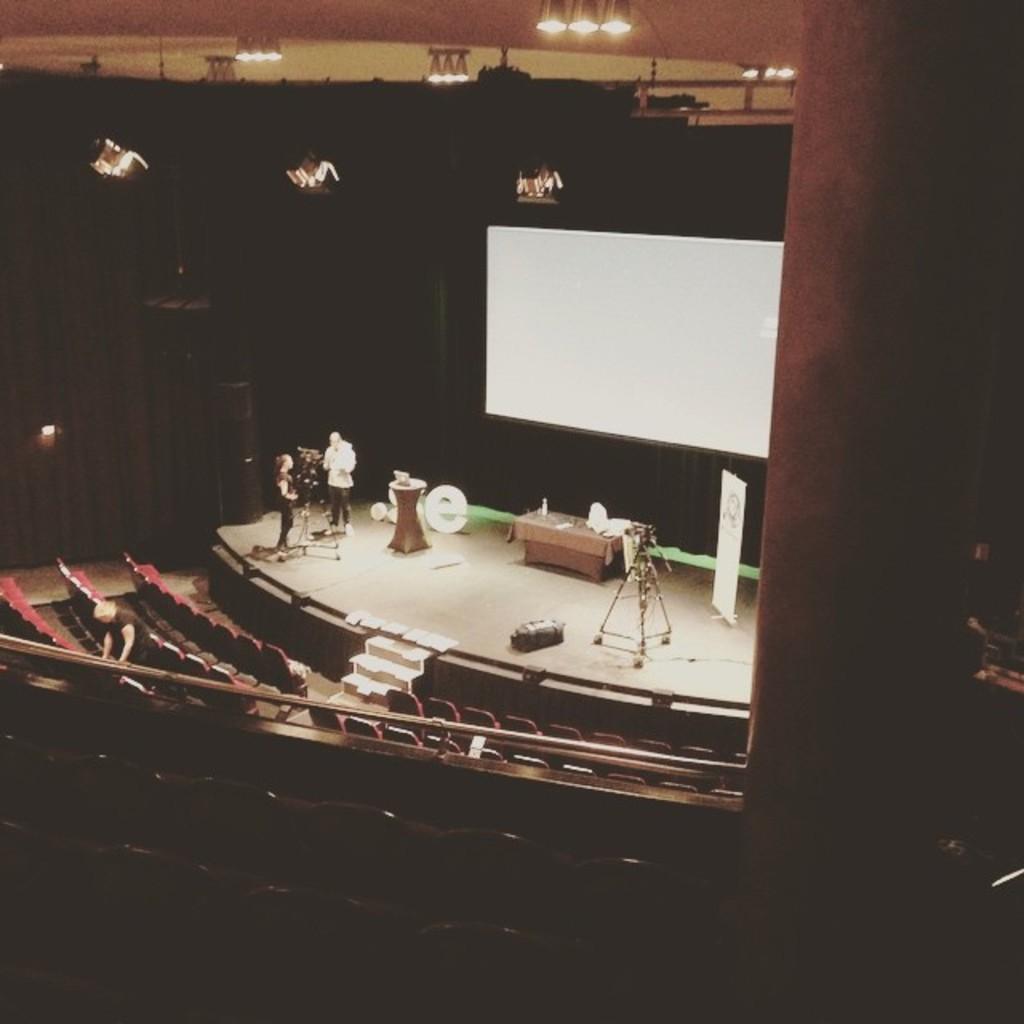Please provide a concise description of this image. In this image in the front there are empty chairs. In the background there are persons standing on the stage and there are objects which are white, black and brown in colour and there is a table, on the table there are objects which are white in colour and there is a screen and there are lights hanging on the top and there is a pillar on the right side and there are steps. 